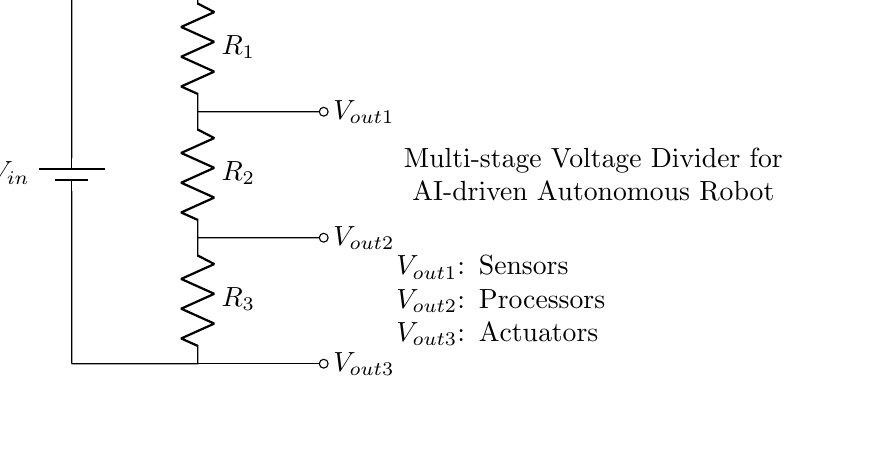What is the input voltage symbolized as? The input voltage in the circuit is represented by the symbol V_in, which is typically placed near the battery component in the diagram.
Answer: V_in How many resistors are in the voltage divider? The voltage divider contains three resistors, indicated as R_1, R_2, and R_3 along the circuit diagram.
Answer: Three What are the outputs used for in the circuit? The outputs labeled V_out1, V_out2, and V_out3 are designated for different components; V_out1 is for sensors, V_out2 for processors, and V_out3 for actuators, based on the annotations in the diagram.
Answer: Sensors, Processors, Actuators What is the relationship between the resistors in a voltage divider? Resistors in a voltage divider are connected in series, which means the total voltage is divided among them according to their resistances. This principle underlies the functionality of the voltage divider.
Answer: Series If R_1 is doubled, how will V_out1 change? If R_1 is doubled, the proportion of V_in across R_1 increases, which leads to an increase in V_out1, since V_out1 is calculated by the formula V_out = V_in * (R_2 / (R_1 + R_2 + R_3)). The voltage drop will rise as the resistance of R_1 increases against the others.
Answer: Increase What is the purpose of a multi-stage voltage divider? A multi-stage voltage divider is used to provide different voltage levels for multiple components, such as sensors and processors in this robot, ensuring the correct operating voltage is delivered to each part.
Answer: Different voltages Which component serves as the power source? The component functioning as the power source is the battery, denoted by the battery symbol near V_in at the top of the diagram.
Answer: Battery 